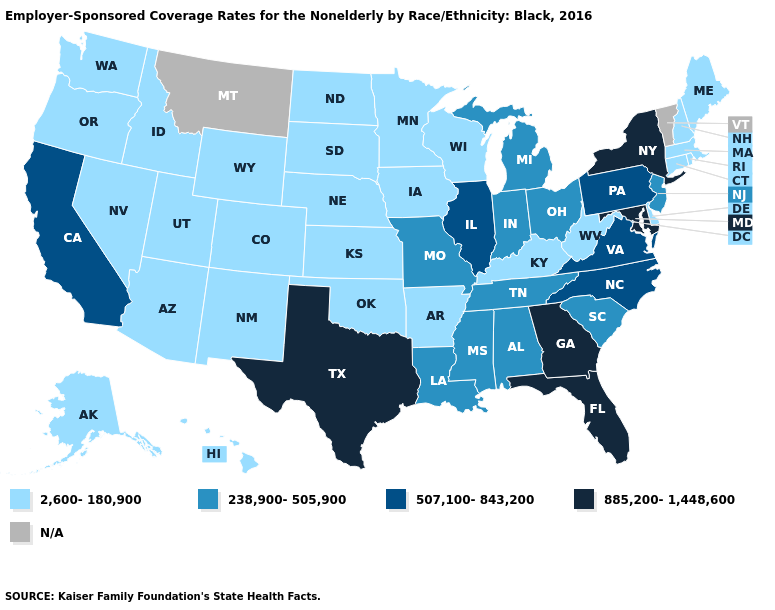Name the states that have a value in the range 238,900-505,900?
Keep it brief. Alabama, Indiana, Louisiana, Michigan, Mississippi, Missouri, New Jersey, Ohio, South Carolina, Tennessee. What is the highest value in states that border Montana?
Short answer required. 2,600-180,900. Name the states that have a value in the range 507,100-843,200?
Be succinct. California, Illinois, North Carolina, Pennsylvania, Virginia. What is the highest value in the USA?
Short answer required. 885,200-1,448,600. Does New York have the highest value in the USA?
Be succinct. Yes. Name the states that have a value in the range 507,100-843,200?
Write a very short answer. California, Illinois, North Carolina, Pennsylvania, Virginia. What is the value of Oklahoma?
Write a very short answer. 2,600-180,900. What is the value of Louisiana?
Give a very brief answer. 238,900-505,900. Among the states that border Missouri , which have the highest value?
Keep it brief. Illinois. What is the lowest value in states that border Kansas?
Be succinct. 2,600-180,900. What is the lowest value in states that border Texas?
Write a very short answer. 2,600-180,900. Among the states that border Rhode Island , which have the lowest value?
Keep it brief. Connecticut, Massachusetts. Name the states that have a value in the range 507,100-843,200?
Keep it brief. California, Illinois, North Carolina, Pennsylvania, Virginia. Does California have the highest value in the West?
Concise answer only. Yes. 